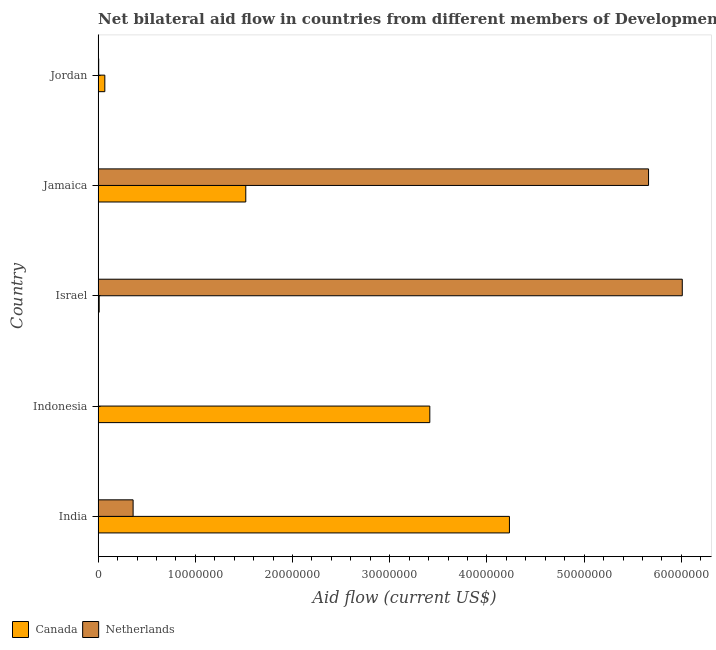How many bars are there on the 5th tick from the top?
Your answer should be compact. 2. What is the label of the 1st group of bars from the top?
Offer a very short reply. Jordan. In how many cases, is the number of bars for a given country not equal to the number of legend labels?
Your answer should be compact. 0. What is the amount of aid given by canada in Jamaica?
Provide a succinct answer. 1.52e+07. Across all countries, what is the maximum amount of aid given by canada?
Provide a short and direct response. 4.23e+07. Across all countries, what is the minimum amount of aid given by netherlands?
Offer a terse response. 10000. What is the total amount of aid given by canada in the graph?
Offer a terse response. 9.24e+07. What is the difference between the amount of aid given by canada in Indonesia and that in Jamaica?
Offer a very short reply. 1.89e+07. What is the difference between the amount of aid given by netherlands in Jamaica and the amount of aid given by canada in Indonesia?
Offer a very short reply. 2.25e+07. What is the average amount of aid given by canada per country?
Keep it short and to the point. 1.85e+07. What is the difference between the amount of aid given by netherlands and amount of aid given by canada in Indonesia?
Ensure brevity in your answer.  -3.41e+07. In how many countries, is the amount of aid given by netherlands greater than 10000000 US$?
Provide a short and direct response. 2. What is the ratio of the amount of aid given by canada in Indonesia to that in Jamaica?
Make the answer very short. 2.25. Is the amount of aid given by netherlands in India less than that in Israel?
Provide a short and direct response. Yes. Is the difference between the amount of aid given by canada in India and Jordan greater than the difference between the amount of aid given by netherlands in India and Jordan?
Provide a succinct answer. Yes. What is the difference between the highest and the second highest amount of aid given by canada?
Ensure brevity in your answer.  8.19e+06. What is the difference between the highest and the lowest amount of aid given by netherlands?
Offer a very short reply. 6.01e+07. Is the sum of the amount of aid given by netherlands in Indonesia and Israel greater than the maximum amount of aid given by canada across all countries?
Offer a very short reply. Yes. What does the 1st bar from the top in Jamaica represents?
Give a very brief answer. Netherlands. What does the 2nd bar from the bottom in Jamaica represents?
Offer a terse response. Netherlands. How many bars are there?
Your answer should be very brief. 10. Are all the bars in the graph horizontal?
Your response must be concise. Yes. Does the graph contain grids?
Keep it short and to the point. No. Where does the legend appear in the graph?
Provide a short and direct response. Bottom left. How many legend labels are there?
Ensure brevity in your answer.  2. What is the title of the graph?
Make the answer very short. Net bilateral aid flow in countries from different members of Development Assistance Committee. Does "ODA received" appear as one of the legend labels in the graph?
Provide a succinct answer. No. What is the Aid flow (current US$) of Canada in India?
Your response must be concise. 4.23e+07. What is the Aid flow (current US$) in Netherlands in India?
Give a very brief answer. 3.60e+06. What is the Aid flow (current US$) in Canada in Indonesia?
Offer a very short reply. 3.41e+07. What is the Aid flow (current US$) of Netherlands in Israel?
Offer a terse response. 6.01e+07. What is the Aid flow (current US$) in Canada in Jamaica?
Give a very brief answer. 1.52e+07. What is the Aid flow (current US$) in Netherlands in Jamaica?
Ensure brevity in your answer.  5.66e+07. What is the Aid flow (current US$) of Canada in Jordan?
Offer a terse response. 6.90e+05. What is the Aid flow (current US$) in Netherlands in Jordan?
Ensure brevity in your answer.  6.00e+04. Across all countries, what is the maximum Aid flow (current US$) of Canada?
Your answer should be compact. 4.23e+07. Across all countries, what is the maximum Aid flow (current US$) of Netherlands?
Your response must be concise. 6.01e+07. Across all countries, what is the minimum Aid flow (current US$) of Netherlands?
Offer a terse response. 10000. What is the total Aid flow (current US$) in Canada in the graph?
Your response must be concise. 9.24e+07. What is the total Aid flow (current US$) of Netherlands in the graph?
Keep it short and to the point. 1.20e+08. What is the difference between the Aid flow (current US$) of Canada in India and that in Indonesia?
Ensure brevity in your answer.  8.19e+06. What is the difference between the Aid flow (current US$) in Netherlands in India and that in Indonesia?
Offer a very short reply. 3.59e+06. What is the difference between the Aid flow (current US$) of Canada in India and that in Israel?
Keep it short and to the point. 4.22e+07. What is the difference between the Aid flow (current US$) in Netherlands in India and that in Israel?
Give a very brief answer. -5.65e+07. What is the difference between the Aid flow (current US$) of Canada in India and that in Jamaica?
Keep it short and to the point. 2.71e+07. What is the difference between the Aid flow (current US$) in Netherlands in India and that in Jamaica?
Your response must be concise. -5.30e+07. What is the difference between the Aid flow (current US$) of Canada in India and that in Jordan?
Your answer should be very brief. 4.16e+07. What is the difference between the Aid flow (current US$) of Netherlands in India and that in Jordan?
Provide a succinct answer. 3.54e+06. What is the difference between the Aid flow (current US$) in Canada in Indonesia and that in Israel?
Your answer should be very brief. 3.40e+07. What is the difference between the Aid flow (current US$) of Netherlands in Indonesia and that in Israel?
Offer a terse response. -6.01e+07. What is the difference between the Aid flow (current US$) of Canada in Indonesia and that in Jamaica?
Your answer should be very brief. 1.89e+07. What is the difference between the Aid flow (current US$) in Netherlands in Indonesia and that in Jamaica?
Ensure brevity in your answer.  -5.66e+07. What is the difference between the Aid flow (current US$) of Canada in Indonesia and that in Jordan?
Your response must be concise. 3.34e+07. What is the difference between the Aid flow (current US$) of Canada in Israel and that in Jamaica?
Provide a succinct answer. -1.51e+07. What is the difference between the Aid flow (current US$) of Netherlands in Israel and that in Jamaica?
Provide a succinct answer. 3.47e+06. What is the difference between the Aid flow (current US$) in Canada in Israel and that in Jordan?
Provide a short and direct response. -5.80e+05. What is the difference between the Aid flow (current US$) of Netherlands in Israel and that in Jordan?
Your answer should be compact. 6.00e+07. What is the difference between the Aid flow (current US$) in Canada in Jamaica and that in Jordan?
Make the answer very short. 1.45e+07. What is the difference between the Aid flow (current US$) of Netherlands in Jamaica and that in Jordan?
Offer a terse response. 5.66e+07. What is the difference between the Aid flow (current US$) in Canada in India and the Aid flow (current US$) in Netherlands in Indonesia?
Keep it short and to the point. 4.23e+07. What is the difference between the Aid flow (current US$) of Canada in India and the Aid flow (current US$) of Netherlands in Israel?
Make the answer very short. -1.78e+07. What is the difference between the Aid flow (current US$) of Canada in India and the Aid flow (current US$) of Netherlands in Jamaica?
Offer a terse response. -1.43e+07. What is the difference between the Aid flow (current US$) of Canada in India and the Aid flow (current US$) of Netherlands in Jordan?
Your response must be concise. 4.22e+07. What is the difference between the Aid flow (current US$) of Canada in Indonesia and the Aid flow (current US$) of Netherlands in Israel?
Offer a terse response. -2.60e+07. What is the difference between the Aid flow (current US$) of Canada in Indonesia and the Aid flow (current US$) of Netherlands in Jamaica?
Keep it short and to the point. -2.25e+07. What is the difference between the Aid flow (current US$) in Canada in Indonesia and the Aid flow (current US$) in Netherlands in Jordan?
Your response must be concise. 3.41e+07. What is the difference between the Aid flow (current US$) of Canada in Israel and the Aid flow (current US$) of Netherlands in Jamaica?
Ensure brevity in your answer.  -5.65e+07. What is the difference between the Aid flow (current US$) of Canada in Israel and the Aid flow (current US$) of Netherlands in Jordan?
Give a very brief answer. 5.00e+04. What is the difference between the Aid flow (current US$) of Canada in Jamaica and the Aid flow (current US$) of Netherlands in Jordan?
Your response must be concise. 1.51e+07. What is the average Aid flow (current US$) in Canada per country?
Your response must be concise. 1.85e+07. What is the average Aid flow (current US$) in Netherlands per country?
Give a very brief answer. 2.41e+07. What is the difference between the Aid flow (current US$) of Canada and Aid flow (current US$) of Netherlands in India?
Give a very brief answer. 3.87e+07. What is the difference between the Aid flow (current US$) in Canada and Aid flow (current US$) in Netherlands in Indonesia?
Your answer should be very brief. 3.41e+07. What is the difference between the Aid flow (current US$) of Canada and Aid flow (current US$) of Netherlands in Israel?
Your response must be concise. -6.00e+07. What is the difference between the Aid flow (current US$) of Canada and Aid flow (current US$) of Netherlands in Jamaica?
Keep it short and to the point. -4.14e+07. What is the difference between the Aid flow (current US$) of Canada and Aid flow (current US$) of Netherlands in Jordan?
Your answer should be very brief. 6.30e+05. What is the ratio of the Aid flow (current US$) of Canada in India to that in Indonesia?
Provide a short and direct response. 1.24. What is the ratio of the Aid flow (current US$) of Netherlands in India to that in Indonesia?
Your answer should be compact. 360. What is the ratio of the Aid flow (current US$) of Canada in India to that in Israel?
Your answer should be compact. 384.64. What is the ratio of the Aid flow (current US$) in Netherlands in India to that in Israel?
Your answer should be compact. 0.06. What is the ratio of the Aid flow (current US$) in Canada in India to that in Jamaica?
Provide a succinct answer. 2.79. What is the ratio of the Aid flow (current US$) of Netherlands in India to that in Jamaica?
Ensure brevity in your answer.  0.06. What is the ratio of the Aid flow (current US$) in Canada in India to that in Jordan?
Ensure brevity in your answer.  61.32. What is the ratio of the Aid flow (current US$) in Canada in Indonesia to that in Israel?
Keep it short and to the point. 310.18. What is the ratio of the Aid flow (current US$) in Canada in Indonesia to that in Jamaica?
Offer a terse response. 2.25. What is the ratio of the Aid flow (current US$) in Netherlands in Indonesia to that in Jamaica?
Your answer should be compact. 0. What is the ratio of the Aid flow (current US$) in Canada in Indonesia to that in Jordan?
Offer a very short reply. 49.45. What is the ratio of the Aid flow (current US$) in Canada in Israel to that in Jamaica?
Offer a very short reply. 0.01. What is the ratio of the Aid flow (current US$) in Netherlands in Israel to that in Jamaica?
Ensure brevity in your answer.  1.06. What is the ratio of the Aid flow (current US$) in Canada in Israel to that in Jordan?
Keep it short and to the point. 0.16. What is the ratio of the Aid flow (current US$) in Netherlands in Israel to that in Jordan?
Ensure brevity in your answer.  1001.5. What is the ratio of the Aid flow (current US$) in Canada in Jamaica to that in Jordan?
Your answer should be very brief. 22.01. What is the ratio of the Aid flow (current US$) in Netherlands in Jamaica to that in Jordan?
Keep it short and to the point. 943.67. What is the difference between the highest and the second highest Aid flow (current US$) of Canada?
Give a very brief answer. 8.19e+06. What is the difference between the highest and the second highest Aid flow (current US$) of Netherlands?
Provide a succinct answer. 3.47e+06. What is the difference between the highest and the lowest Aid flow (current US$) in Canada?
Provide a succinct answer. 4.22e+07. What is the difference between the highest and the lowest Aid flow (current US$) in Netherlands?
Provide a succinct answer. 6.01e+07. 